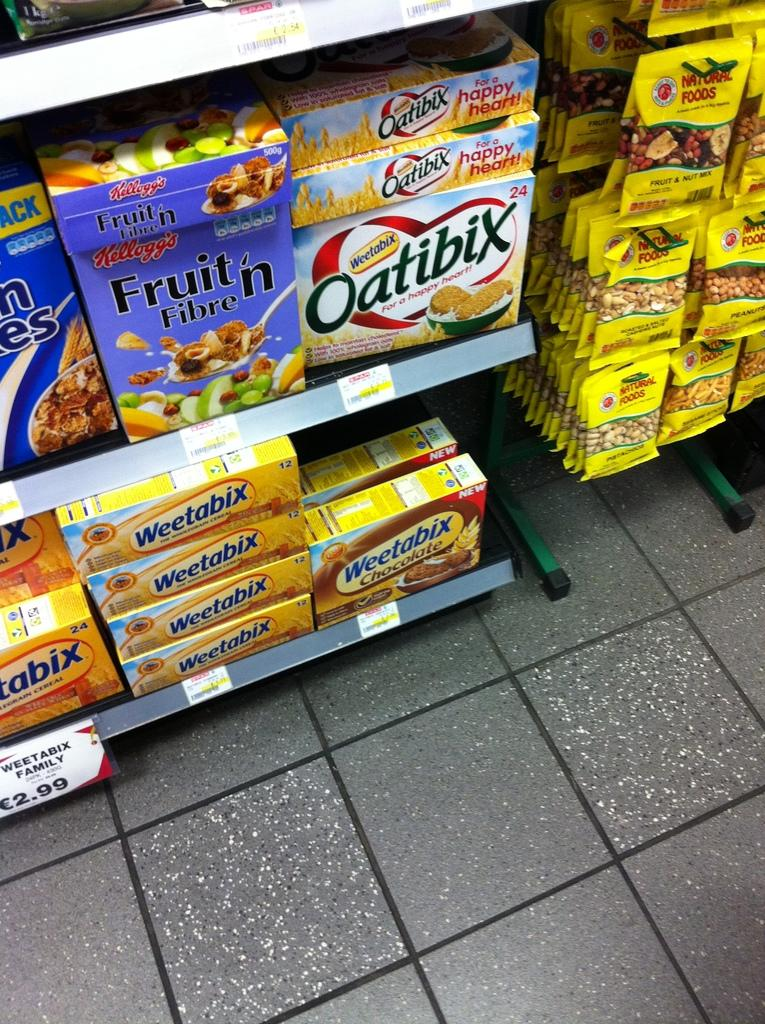<image>
Write a terse but informative summary of the picture. the word oatbix is on the front of the box 